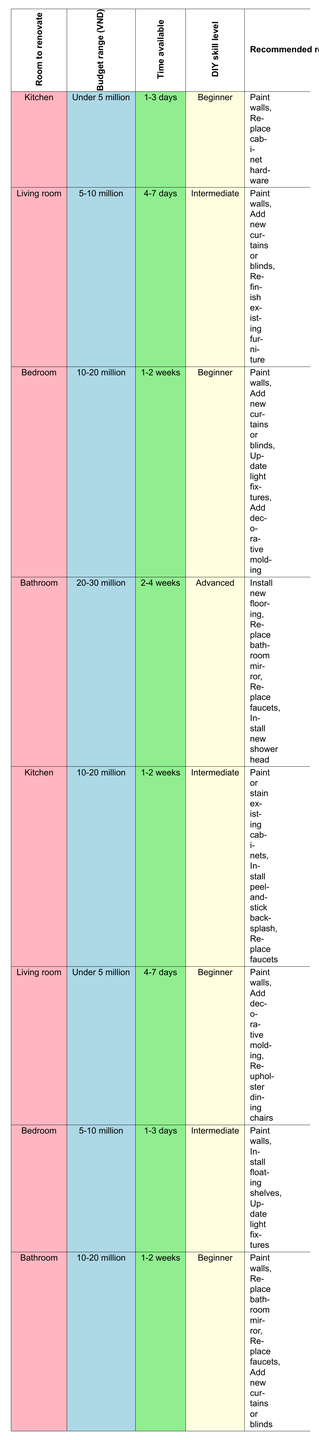What are the recommended renovation options for a Bedroom with a budget between 10-20 million and a Beginner DIY skill level? To find the answer, we refer to the table and look for the row that corresponds to "Bedroom," "10-20 million," and "Beginner." The matching row shows the recommended options as: "Paint walls, Add new curtains or blinds, Update light fixtures, Add decorative molding."
Answer: Paint walls, Add new curtains or blinds, Update light fixtures, Add decorative molding Is it possible to renovate a Living room with a budget under 5 million in less than a week with a Beginner skill level? According to the table, there is a row for "Living room," "Under 5 million," "4-7 days," and "Beginner," indicating that this is possible. The recommended options are "Paint walls, Add decorative molding, Reupholster dining chairs."
Answer: Yes What renovations can be done in the Bathroom within a budget of 10-20 million with a Beginner skill level? We look for the "Bathroom," "10-20 million," and "Beginner" in the table. The corresponding row indicates the options: "Paint walls, Replace bathroom mirror, Replace faucets, Add new curtains or blinds."
Answer: Paint walls, Replace bathroom mirror, Replace faucets, Add new curtains or blinds Which renovation option has the highest budget requirement and what is the estimated budget? In the table, the highest budget category shown is "20-30 million," which appears only for "Bathroom." The options listed are "Install new flooring, Replace bathroom mirror, Replace faucets, Install new shower head." Hence, the highest budget requirement for renovation is 20-30 million.
Answer: 20-30 million In total, how many recommended renovation options are available for a Kitchen with a budget between 10-20 million and Intermediate DIY skill level? We check the table for "Kitchen," "10-20 million," and "Intermediate." The row shows three options: "Paint or stain existing cabinets, Install peel-and-stick backsplash, Replace faucets." Thus, we count these options.
Answer: 3 